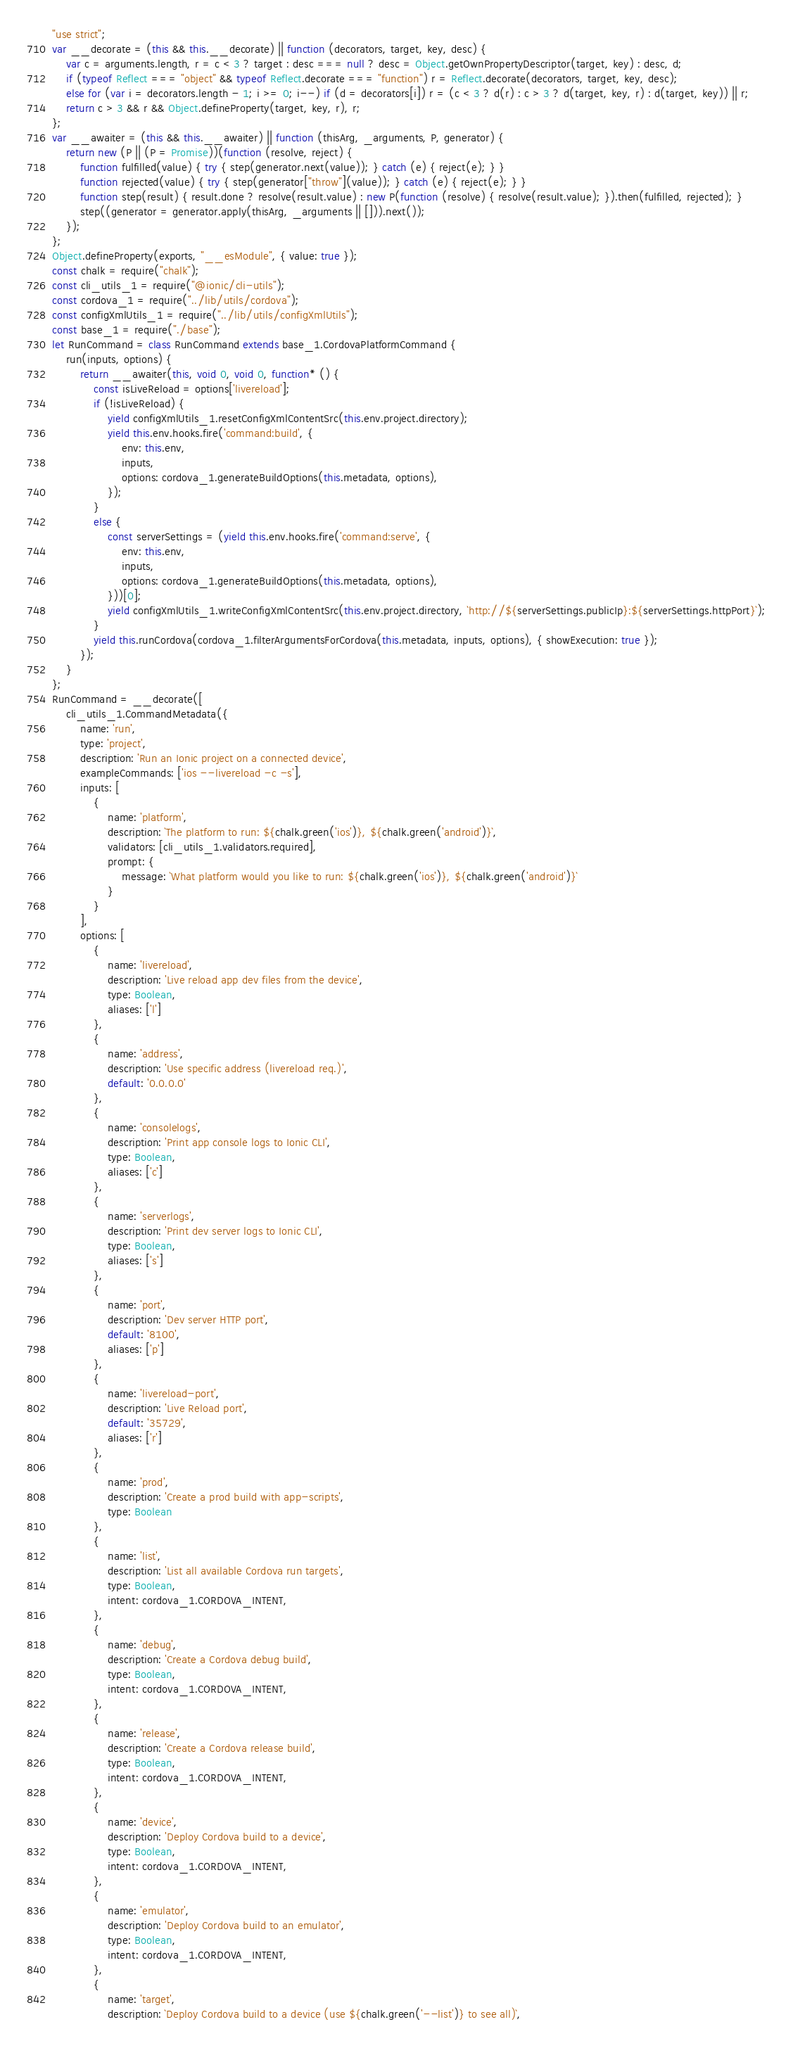Convert code to text. <code><loc_0><loc_0><loc_500><loc_500><_JavaScript_>"use strict";
var __decorate = (this && this.__decorate) || function (decorators, target, key, desc) {
    var c = arguments.length, r = c < 3 ? target : desc === null ? desc = Object.getOwnPropertyDescriptor(target, key) : desc, d;
    if (typeof Reflect === "object" && typeof Reflect.decorate === "function") r = Reflect.decorate(decorators, target, key, desc);
    else for (var i = decorators.length - 1; i >= 0; i--) if (d = decorators[i]) r = (c < 3 ? d(r) : c > 3 ? d(target, key, r) : d(target, key)) || r;
    return c > 3 && r && Object.defineProperty(target, key, r), r;
};
var __awaiter = (this && this.__awaiter) || function (thisArg, _arguments, P, generator) {
    return new (P || (P = Promise))(function (resolve, reject) {
        function fulfilled(value) { try { step(generator.next(value)); } catch (e) { reject(e); } }
        function rejected(value) { try { step(generator["throw"](value)); } catch (e) { reject(e); } }
        function step(result) { result.done ? resolve(result.value) : new P(function (resolve) { resolve(result.value); }).then(fulfilled, rejected); }
        step((generator = generator.apply(thisArg, _arguments || [])).next());
    });
};
Object.defineProperty(exports, "__esModule", { value: true });
const chalk = require("chalk");
const cli_utils_1 = require("@ionic/cli-utils");
const cordova_1 = require("../lib/utils/cordova");
const configXmlUtils_1 = require("../lib/utils/configXmlUtils");
const base_1 = require("./base");
let RunCommand = class RunCommand extends base_1.CordovaPlatformCommand {
    run(inputs, options) {
        return __awaiter(this, void 0, void 0, function* () {
            const isLiveReload = options['livereload'];
            if (!isLiveReload) {
                yield configXmlUtils_1.resetConfigXmlContentSrc(this.env.project.directory);
                yield this.env.hooks.fire('command:build', {
                    env: this.env,
                    inputs,
                    options: cordova_1.generateBuildOptions(this.metadata, options),
                });
            }
            else {
                const serverSettings = (yield this.env.hooks.fire('command:serve', {
                    env: this.env,
                    inputs,
                    options: cordova_1.generateBuildOptions(this.metadata, options),
                }))[0];
                yield configXmlUtils_1.writeConfigXmlContentSrc(this.env.project.directory, `http://${serverSettings.publicIp}:${serverSettings.httpPort}`);
            }
            yield this.runCordova(cordova_1.filterArgumentsForCordova(this.metadata, inputs, options), { showExecution: true });
        });
    }
};
RunCommand = __decorate([
    cli_utils_1.CommandMetadata({
        name: 'run',
        type: 'project',
        description: 'Run an Ionic project on a connected device',
        exampleCommands: ['ios --livereload -c -s'],
        inputs: [
            {
                name: 'platform',
                description: `The platform to run: ${chalk.green('ios')}, ${chalk.green('android')}`,
                validators: [cli_utils_1.validators.required],
                prompt: {
                    message: `What platform would you like to run: ${chalk.green('ios')}, ${chalk.green('android')}`
                }
            }
        ],
        options: [
            {
                name: 'livereload',
                description: 'Live reload app dev files from the device',
                type: Boolean,
                aliases: ['l']
            },
            {
                name: 'address',
                description: 'Use specific address (livereload req.)',
                default: '0.0.0.0'
            },
            {
                name: 'consolelogs',
                description: 'Print app console logs to Ionic CLI',
                type: Boolean,
                aliases: ['c']
            },
            {
                name: 'serverlogs',
                description: 'Print dev server logs to Ionic CLI',
                type: Boolean,
                aliases: ['s']
            },
            {
                name: 'port',
                description: 'Dev server HTTP port',
                default: '8100',
                aliases: ['p']
            },
            {
                name: 'livereload-port',
                description: 'Live Reload port',
                default: '35729',
                aliases: ['r']
            },
            {
                name: 'prod',
                description: 'Create a prod build with app-scripts',
                type: Boolean
            },
            {
                name: 'list',
                description: 'List all available Cordova run targets',
                type: Boolean,
                intent: cordova_1.CORDOVA_INTENT,
            },
            {
                name: 'debug',
                description: 'Create a Cordova debug build',
                type: Boolean,
                intent: cordova_1.CORDOVA_INTENT,
            },
            {
                name: 'release',
                description: 'Create a Cordova release build',
                type: Boolean,
                intent: cordova_1.CORDOVA_INTENT,
            },
            {
                name: 'device',
                description: 'Deploy Cordova build to a device',
                type: Boolean,
                intent: cordova_1.CORDOVA_INTENT,
            },
            {
                name: 'emulator',
                description: 'Deploy Cordova build to an emulator',
                type: Boolean,
                intent: cordova_1.CORDOVA_INTENT,
            },
            {
                name: 'target',
                description: `Deploy Cordova build to a device (use ${chalk.green('--list')} to see all)`,</code> 